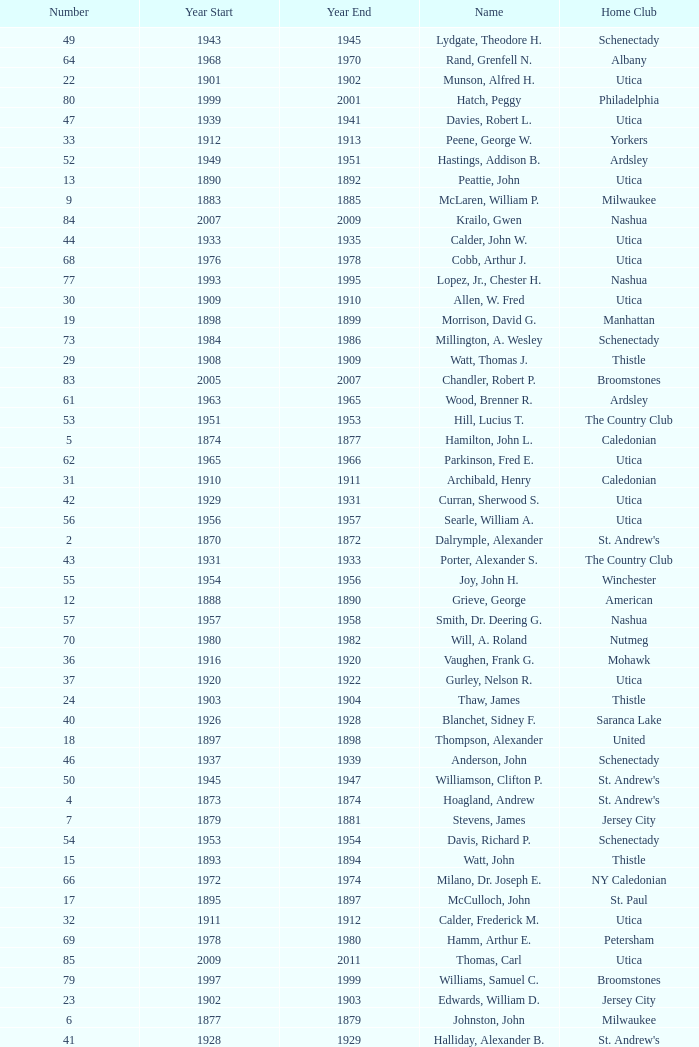Which Year Start has a Number of 28? 1907.0. Can you give me this table as a dict? {'header': ['Number', 'Year Start', 'Year End', 'Name', 'Home Club'], 'rows': [['49', '1943', '1945', 'Lydgate, Theodore H.', 'Schenectady'], ['64', '1968', '1970', 'Rand, Grenfell N.', 'Albany'], ['22', '1901', '1902', 'Munson, Alfred H.', 'Utica'], ['80', '1999', '2001', 'Hatch, Peggy', 'Philadelphia'], ['47', '1939', '1941', 'Davies, Robert L.', 'Utica'], ['33', '1912', '1913', 'Peene, George W.', 'Yorkers'], ['52', '1949', '1951', 'Hastings, Addison B.', 'Ardsley'], ['13', '1890', '1892', 'Peattie, John', 'Utica'], ['9', '1883', '1885', 'McLaren, William P.', 'Milwaukee'], ['84', '2007', '2009', 'Krailo, Gwen', 'Nashua'], ['44', '1933', '1935', 'Calder, John W.', 'Utica'], ['68', '1976', '1978', 'Cobb, Arthur J.', 'Utica'], ['77', '1993', '1995', 'Lopez, Jr., Chester H.', 'Nashua'], ['30', '1909', '1910', 'Allen, W. Fred', 'Utica'], ['19', '1898', '1899', 'Morrison, David G.', 'Manhattan'], ['73', '1984', '1986', 'Millington, A. Wesley', 'Schenectady'], ['29', '1908', '1909', 'Watt, Thomas J.', 'Thistle'], ['83', '2005', '2007', 'Chandler, Robert P.', 'Broomstones'], ['61', '1963', '1965', 'Wood, Brenner R.', 'Ardsley'], ['53', '1951', '1953', 'Hill, Lucius T.', 'The Country Club'], ['5', '1874', '1877', 'Hamilton, John L.', 'Caledonian'], ['62', '1965', '1966', 'Parkinson, Fred E.', 'Utica'], ['31', '1910', '1911', 'Archibald, Henry', 'Caledonian'], ['42', '1929', '1931', 'Curran, Sherwood S.', 'Utica'], ['56', '1956', '1957', 'Searle, William A.', 'Utica'], ['2', '1870', '1872', 'Dalrymple, Alexander', "St. Andrew's"], ['43', '1931', '1933', 'Porter, Alexander S.', 'The Country Club'], ['55', '1954', '1956', 'Joy, John H.', 'Winchester'], ['12', '1888', '1890', 'Grieve, George', 'American'], ['57', '1957', '1958', 'Smith, Dr. Deering G.', 'Nashua'], ['70', '1980', '1982', 'Will, A. Roland', 'Nutmeg'], ['36', '1916', '1920', 'Vaughen, Frank G.', 'Mohawk'], ['37', '1920', '1922', 'Gurley, Nelson R.', 'Utica'], ['24', '1903', '1904', 'Thaw, James', 'Thistle'], ['40', '1926', '1928', 'Blanchet, Sidney F.', 'Saranca Lake'], ['18', '1897', '1898', 'Thompson, Alexander', 'United'], ['46', '1937', '1939', 'Anderson, John', 'Schenectady'], ['50', '1945', '1947', 'Williamson, Clifton P.', "St. Andrew's"], ['4', '1873', '1874', 'Hoagland, Andrew', "St. Andrew's"], ['7', '1879', '1881', 'Stevens, James', 'Jersey City'], ['54', '1953', '1954', 'Davis, Richard P.', 'Schenectady'], ['15', '1893', '1894', 'Watt, John', 'Thistle'], ['66', '1972', '1974', 'Milano, Dr. Joseph E.', 'NY Caledonian'], ['17', '1895', '1897', 'McCulloch, John', 'St. Paul'], ['32', '1911', '1912', 'Calder, Frederick M.', 'Utica'], ['69', '1978', '1980', 'Hamm, Arthur E.', 'Petersham'], ['85', '2009', '2011', 'Thomas, Carl', 'Utica'], ['79', '1997', '1999', 'Williams, Samuel C.', 'Broomstones'], ['23', '1902', '1903', 'Edwards, William D.', 'Jersey City'], ['6', '1877', '1879', 'Johnston, John', 'Milwaukee'], ['41', '1928', '1929', 'Halliday, Alexander B.', "St. Andrew's"], ['10', '1885', '1887', 'Stewart, James', 'Yorkers'], ['72', '1984', '1986', 'Porter, David R.', 'Wellesley'], ['67', '1974', '1976', 'Neuber, Dr. Richard A.', 'Schenectady'], ['8', '1881', '1883', 'Patterson, John', 'New York'], ['51', '1947', '1949', 'Hurd, Kenneth S.', 'Utica'], ['82', '2003', '2005', 'Pelletier, Robert', 'Potomac'], ['75', '1989', '1991', 'Owens, Charles D.', 'Nutmeg'], ['3', '1872', '1873', 'Macnoe, George', 'Caledonian'], ['81', '2001', '2003', 'Garber, Thomas', 'Utica'], ['1', '1867', '1870', 'Bell, David', 'Caledonian'], ['21', '1900', '1901', 'Conley, James F.', 'Empire City'], ['60', '1961', '1963', 'Cushing, Henry K.', 'The Country Club'], ['71', '1982', '1984', 'Cooper, C. Kenneth', 'NY Caledonian'], ['39', '1923', '1926', 'Farrell, Thomas H.', 'Utica'], ['35', '1914', '1916', 'Johnson, Delos M.', 'Utica'], ['48', '1941', '1943', 'King, Franklin', 'The Country Club'], ['78', '1995', '1997', 'Freeman, Kim', 'Schenectady'], ['63', '1966', '1968', 'Childs, Edward C.', 'Norfolk'], ['28', '1907', '1908', 'Lehmann, John A.', 'Empire'], ['20', '1899', '1900', 'McGaw, John', 'Boston'], ['38', '1922', '1923', 'Cluett, Walter H.', 'The Pines'], ['86', '2011', '2013', 'Macartney, Dick', 'Coastal Carolina'], ['59', '1959', '1961', 'Reid, Ralston B.', 'Schenectady'], ['34', '1913', '1914', 'Emmet, Richard S.', 'Mohawk'], ['45', '1935', '1937', 'Patterson, Jr., C. Campbell', 'The Country Club'], ['11', '1887', '1888', 'McArthur, John', 'Chicago'], ['58', '1958', '1959', 'Seibert, W. Lincoln', "St. Andrew's"], ['16', '1894', '1895', 'Thomas, Edwin L.', 'Yorkers'], ['65', '1970', '1972', 'Neill, Stanley E.', 'Winchester'], ['25', '1904', '1905', 'Allen, George B.', 'Utica'], ['76', '1991', '1993', 'Mitchell, J. Peter', 'Garden State'], ['74', '1988', '1989', 'Dewees, Dr. David C.', 'Cape Cod'], ['26', '1905', '1906', 'MacNee, Forrest', "St. Andrew's"], ['14', '1892', '1893', 'Nicholson, Thomas', "St. Andrew's"], ['27', '1906', '1907', 'Johnson, Herman I.', 'Utica']]} 